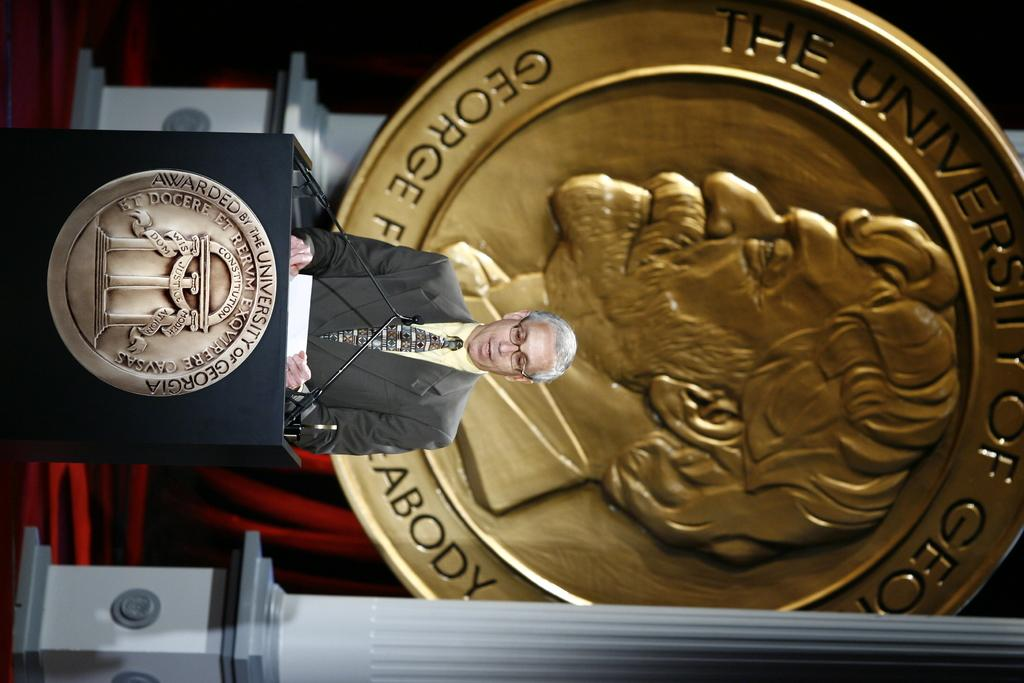<image>
Share a concise interpretation of the image provided. The speech is taking place at the University of Georgia 